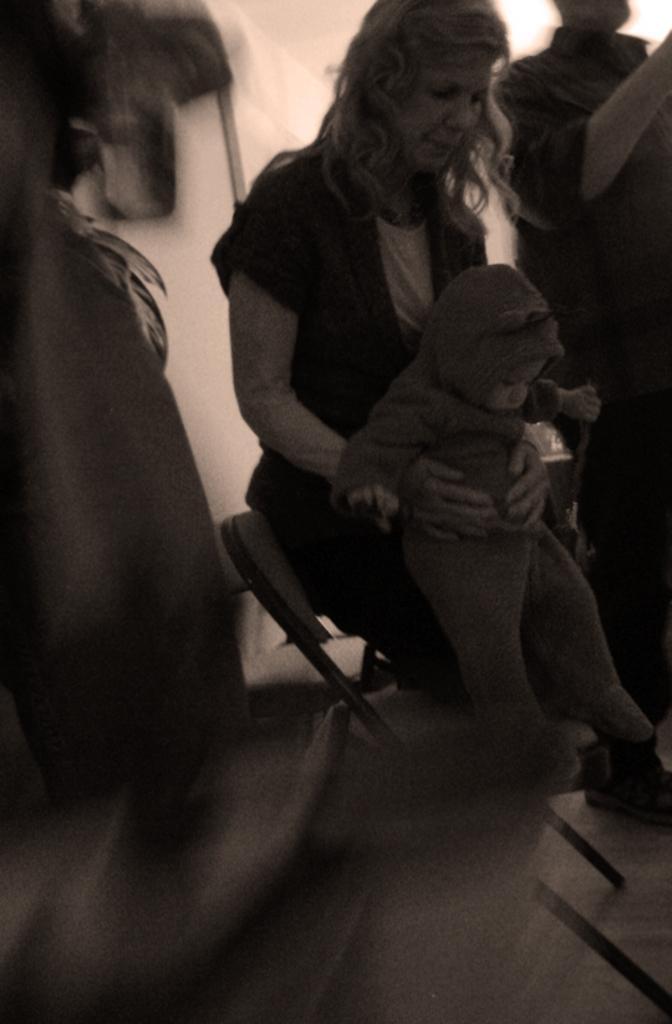Please provide a concise description of this image. In this image there are people standing and a woman is holding a baby in her hand and there is a chair on the left side it is blurred. 